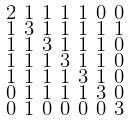Convert formula to latex. <formula><loc_0><loc_0><loc_500><loc_500>\begin{smallmatrix} 2 & 1 & 1 & 1 & 1 & 0 & 0 \\ 1 & 3 & 1 & 1 & 1 & 1 & 1 \\ 1 & 1 & 3 & 1 & 1 & 1 & 0 \\ 1 & 1 & 1 & 3 & 1 & 1 & 0 \\ 1 & 1 & 1 & 1 & 3 & 1 & 0 \\ 0 & 1 & 1 & 1 & 1 & 3 & 0 \\ 0 & 1 & 0 & 0 & 0 & 0 & 3 \end{smallmatrix}</formula> 